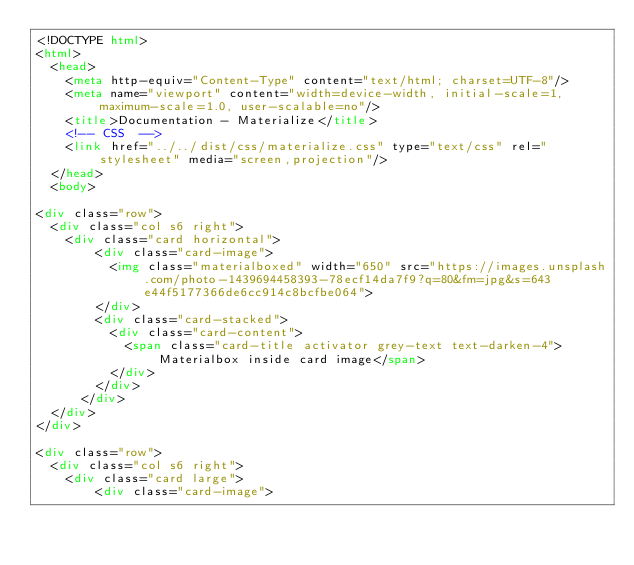<code> <loc_0><loc_0><loc_500><loc_500><_HTML_><!DOCTYPE html>
<html>
  <head>
    <meta http-equiv="Content-Type" content="text/html; charset=UTF-8"/>
    <meta name="viewport" content="width=device-width, initial-scale=1, maximum-scale=1.0, user-scalable=no"/>
    <title>Documentation - Materialize</title>
    <!-- CSS  -->
    <link href="../../dist/css/materialize.css" type="text/css" rel="stylesheet" media="screen,projection"/>
  </head>
  <body>

<div class="row">
  <div class="col s6 right">
    <div class="card horizontal">
        <div class="card-image">
          <img class="materialboxed" width="650" src="https://images.unsplash.com/photo-1439694458393-78ecf14da7f9?q=80&fm=jpg&s=643e44f5177366de6cc914c8bcfbe064">
        </div>
        <div class="card-stacked">
          <div class="card-content">
            <span class="card-title activator grey-text text-darken-4">Materialbox inside card image</span>
          </div>
        </div>
      </div>
  </div>
</div>

<div class="row">
  <div class="col s6 right">
    <div class="card large">
        <div class="card-image"></code> 